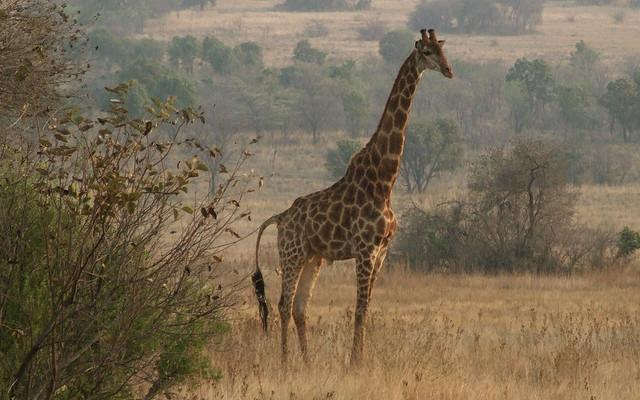How many giraffes are in the picture?
Give a very brief answer. 1. How many giraffes are walking around?
Give a very brief answer. 1. How many animals are in this scene?
Give a very brief answer. 1. How many giraffes are there?
Give a very brief answer. 1. How many giraffes?
Give a very brief answer. 1. 